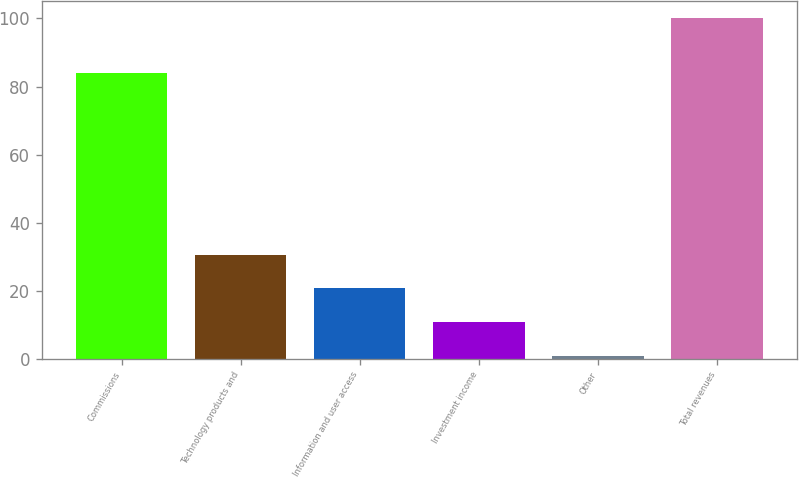Convert chart to OTSL. <chart><loc_0><loc_0><loc_500><loc_500><bar_chart><fcel>Commissions<fcel>Technology products and<fcel>Information and user access<fcel>Investment income<fcel>Other<fcel>Total revenues<nl><fcel>84<fcel>30.63<fcel>20.72<fcel>10.81<fcel>0.9<fcel>100<nl></chart> 